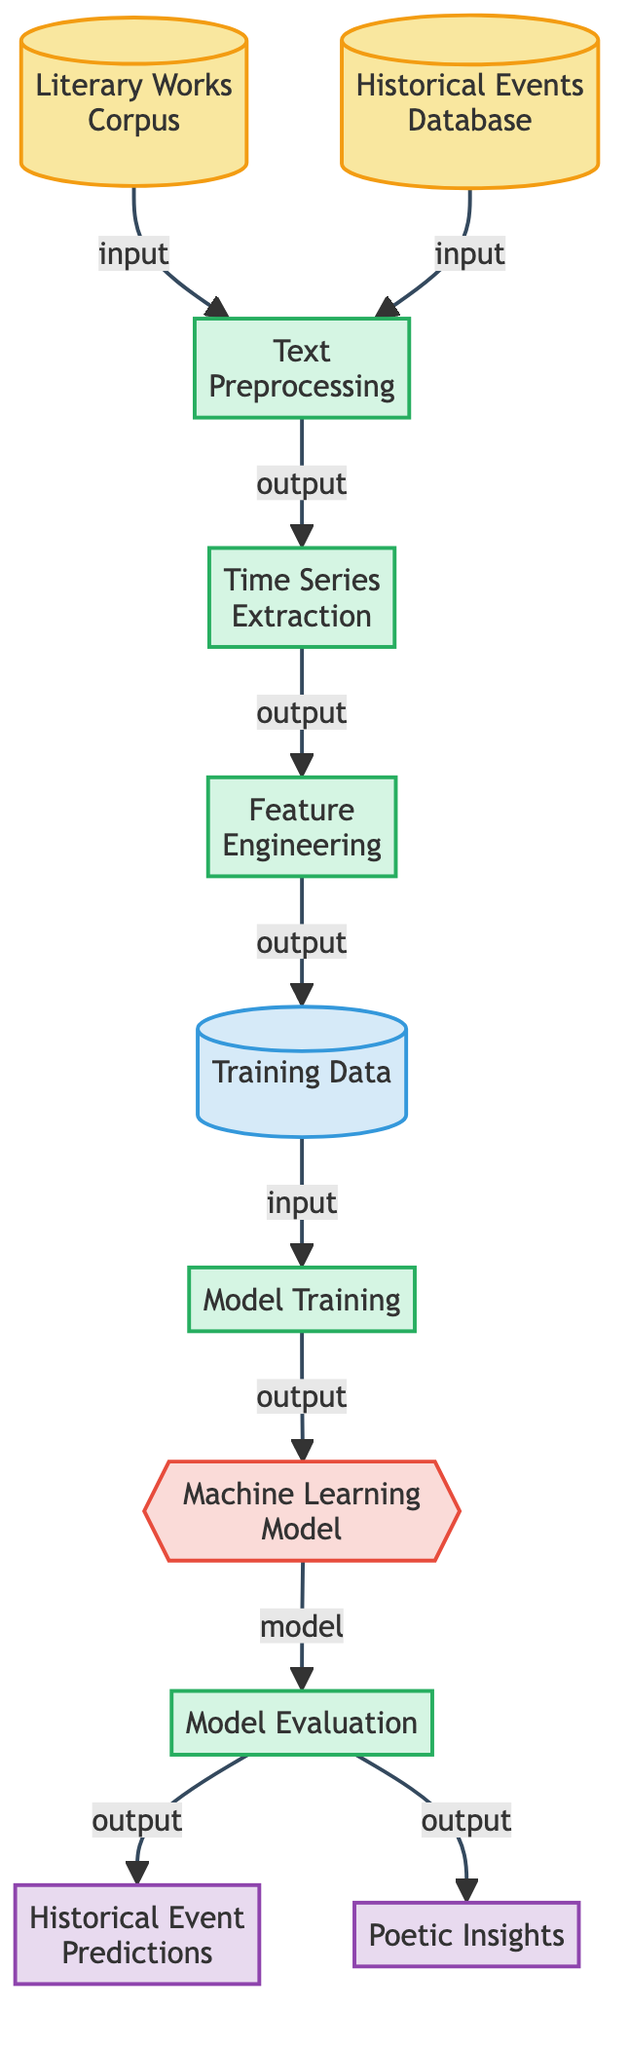What are the two data sources in this diagram? The diagram identifies two data sources: "Literary Works Corpus" and "Historical Events Database" connected to the text preprocessing node.
Answer: Literary Works Corpus, Historical Events Database What is the first process in the flowchart? The first process in the flowchart is titled "Text Preprocessing," which follows after the data sources are inputted into the diagram.
Answer: Text Preprocessing How many processes are depicted in the diagram? By counting the individual process nodes, which include Text Preprocessing, Time Series Extraction, Feature Engineering, Model Training, and Model Evaluation, we find there are five processes in total.
Answer: 5 Which node serves as the output for historical event predictions? The output node labeled "Historical Event Predictions" directly follows the "Model Evaluation" node, indicating it is the result of the forecasting process.
Answer: Historical Event Predictions What is the relationship between "Feature Engineering" and "Training Data"? The "Feature Engineering" node outputs into the "Training Data" node, indicating that the features are utilized to create the training dataset for the machine learning model.
Answer: outputs to What is the purpose of the "Machine Learning Model" node? The "Machine Learning Model" node serves as a container for the model that is being trained and evaluated based on the training data processed prior.
Answer: Train machine learning model What output is generated alongside the historical event predictions? The diagram indicates that alongside the "Historical Event Predictions," there is also an output labeled "Poetic Insights," suggesting a creative interpretation of the predictions.
Answer: Poetic Insights What is the primary function of the "Model Evaluation" process? The "Model Evaluation" process assesses the performance and accuracy of the trained machine learning model to ensure its predictive capabilities are satisfactory.
Answer: Assess accuracy How is the "Training Data" connected to the diagram's processes? The "Training Data" is derived from the output of the "Feature Engineering" process, which demonstrates the flow from feature creation to utilizing those features for training the model.
Answer: Connecting feature extraction to training model 